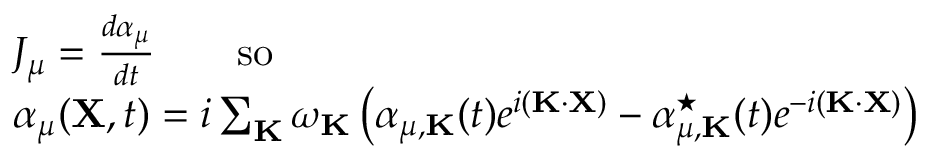Convert formula to latex. <formula><loc_0><loc_0><loc_500><loc_500>\begin{array} { r l } & { J _ { \mu } = \frac { d \alpha _ { \mu } } { d t } \quad s o } \\ & { \alpha _ { \mu } ( { X } , t ) = i \sum _ { K } \omega _ { K } \left ( \alpha _ { \mu , { K } } ( t ) e ^ { i ( { K } \cdot { X } ) } - \alpha _ { \mu , { K } } ^ { ^ { * } } ( t ) e ^ { - i ( { K } \cdot { X } ) } \right ) } \end{array}</formula> 